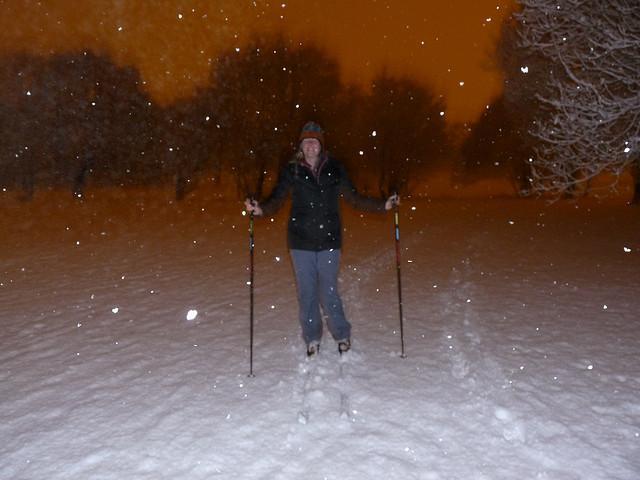How many dolphins are painted on the boats in this photo?
Give a very brief answer. 0. 